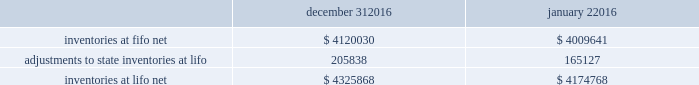Advance auto parts , inc .
And subsidiaries notes to the consolidated financial statements december 31 , 2016 , january 2 , 2016 and january 3 , 2015 ( in thousands , except per share data ) 2 .
Inventories , net : merchandise inventory the company used the lifo method of accounting for approximately 89% ( 89 % ) of inventories at both december 31 , 2016 and january 2 , 2016 .
Under lifo , the company 2019s cost of sales reflects the costs of the most recently purchased inventories , while the inventory carrying balance represents the costs for inventories purchased in 2016 and prior years .
As a result of utilizing lifo , the company recorded a reduction to cost of sales of $ 40711 and $ 42295 in 2016 and 2015 , respectively , and an increase to cost of sales of $ 8930 in 2014 .
Historically , the company 2019s overall costs to acquire inventory for the same or similar products have generally decreased as the company has been able to leverage its continued growth and execution of merchandise strategies .
The increase in cost of sales for 2014 was the result of an increase in supply chain costs .
Product cores the remaining inventories are comprised of product cores , the non-consumable portion of certain parts and batteries and the inventory of certain subsidiaries , which are valued under the first-in , first-out ( 201cfifo 201d ) method .
Product cores are included as part of the company 2019s merchandise costs and are either passed on to the customer or returned to the vendor .
Because product cores are not subject to frequent cost changes like the company 2019s other merchandise inventory , there is no material difference when applying either the lifo or fifo valuation method .
Inventory overhead costs purchasing and warehousing costs included in inventory as of december 31 , 2016 and january 2 , 2016 , were $ 395240 and $ 359829 , respectively .
Inventory balance and inventory reserves inventory balances at the end of 2016 and 2015 were as follows : december 31 , january 2 .
Inventory quantities are tracked through a perpetual inventory system .
The company completes physical inventories and other targeted inventory counts in its store locations to ensure the accuracy of the perpetual inventory quantities of merchandise and core inventory .
In its distribution centers and branches , the company uses a cycle counting program to ensure the accuracy of the perpetual inventory quantities of merchandise and product core inventory .
Reserves for estimated shrink are established based on the results of physical inventories conducted by the company and other targeted inventory counts in its stores , results from recent cycle counts in its distribution facilities and historical and current loss trends .
The company also establishes reserves for potentially excess and obsolete inventories based on ( i ) current inventory levels , ( ii ) the historical analysis of product sales and ( iii ) current market conditions .
The company has return rights with many of its vendors and the majority of excess inventory is returned to its vendors for full credit .
In certain situations , the company establishes reserves when less than full credit is expected from a vendor or when liquidating product will result in retail prices below recorded costs. .
How the cash flow from operations affected by the increase in inventories at lifo net in 2016? 
Computations: (4174768 - 4325868)
Answer: -151100.0. Advance auto parts , inc .
And subsidiaries notes to the consolidated financial statements december 31 , 2016 , january 2 , 2016 and january 3 , 2015 ( in thousands , except per share data ) 2 .
Inventories , net : merchandise inventory the company used the lifo method of accounting for approximately 89% ( 89 % ) of inventories at both december 31 , 2016 and january 2 , 2016 .
Under lifo , the company 2019s cost of sales reflects the costs of the most recently purchased inventories , while the inventory carrying balance represents the costs for inventories purchased in 2016 and prior years .
As a result of utilizing lifo , the company recorded a reduction to cost of sales of $ 40711 and $ 42295 in 2016 and 2015 , respectively , and an increase to cost of sales of $ 8930 in 2014 .
Historically , the company 2019s overall costs to acquire inventory for the same or similar products have generally decreased as the company has been able to leverage its continued growth and execution of merchandise strategies .
The increase in cost of sales for 2014 was the result of an increase in supply chain costs .
Product cores the remaining inventories are comprised of product cores , the non-consumable portion of certain parts and batteries and the inventory of certain subsidiaries , which are valued under the first-in , first-out ( 201cfifo 201d ) method .
Product cores are included as part of the company 2019s merchandise costs and are either passed on to the customer or returned to the vendor .
Because product cores are not subject to frequent cost changes like the company 2019s other merchandise inventory , there is no material difference when applying either the lifo or fifo valuation method .
Inventory overhead costs purchasing and warehousing costs included in inventory as of december 31 , 2016 and january 2 , 2016 , were $ 395240 and $ 359829 , respectively .
Inventory balance and inventory reserves inventory balances at the end of 2016 and 2015 were as follows : december 31 , january 2 .
Inventory quantities are tracked through a perpetual inventory system .
The company completes physical inventories and other targeted inventory counts in its store locations to ensure the accuracy of the perpetual inventory quantities of merchandise and core inventory .
In its distribution centers and branches , the company uses a cycle counting program to ensure the accuracy of the perpetual inventory quantities of merchandise and product core inventory .
Reserves for estimated shrink are established based on the results of physical inventories conducted by the company and other targeted inventory counts in its stores , results from recent cycle counts in its distribution facilities and historical and current loss trends .
The company also establishes reserves for potentially excess and obsolete inventories based on ( i ) current inventory levels , ( ii ) the historical analysis of product sales and ( iii ) current market conditions .
The company has return rights with many of its vendors and the majority of excess inventory is returned to its vendors for full credit .
In certain situations , the company establishes reserves when less than full credit is expected from a vendor or when liquidating product will result in retail prices below recorded costs. .
How the cash flow from operations affected by the increase in inventories at fifo net in 2016? 
Computations: (4009641 - 4120030)
Answer: -110389.0. Advance auto parts , inc .
And subsidiaries notes to the consolidated financial statements december 31 , 2016 , january 2 , 2016 and january 3 , 2015 ( in thousands , except per share data ) 2 .
Inventories , net : merchandise inventory the company used the lifo method of accounting for approximately 89% ( 89 % ) of inventories at both december 31 , 2016 and january 2 , 2016 .
Under lifo , the company 2019s cost of sales reflects the costs of the most recently purchased inventories , while the inventory carrying balance represents the costs for inventories purchased in 2016 and prior years .
As a result of utilizing lifo , the company recorded a reduction to cost of sales of $ 40711 and $ 42295 in 2016 and 2015 , respectively , and an increase to cost of sales of $ 8930 in 2014 .
Historically , the company 2019s overall costs to acquire inventory for the same or similar products have generally decreased as the company has been able to leverage its continued growth and execution of merchandise strategies .
The increase in cost of sales for 2014 was the result of an increase in supply chain costs .
Product cores the remaining inventories are comprised of product cores , the non-consumable portion of certain parts and batteries and the inventory of certain subsidiaries , which are valued under the first-in , first-out ( 201cfifo 201d ) method .
Product cores are included as part of the company 2019s merchandise costs and are either passed on to the customer or returned to the vendor .
Because product cores are not subject to frequent cost changes like the company 2019s other merchandise inventory , there is no material difference when applying either the lifo or fifo valuation method .
Inventory overhead costs purchasing and warehousing costs included in inventory as of december 31 , 2016 and january 2 , 2016 , were $ 395240 and $ 359829 , respectively .
Inventory balance and inventory reserves inventory balances at the end of 2016 and 2015 were as follows : december 31 , january 2 .
Inventory quantities are tracked through a perpetual inventory system .
The company completes physical inventories and other targeted inventory counts in its store locations to ensure the accuracy of the perpetual inventory quantities of merchandise and core inventory .
In its distribution centers and branches , the company uses a cycle counting program to ensure the accuracy of the perpetual inventory quantities of merchandise and product core inventory .
Reserves for estimated shrink are established based on the results of physical inventories conducted by the company and other targeted inventory counts in its stores , results from recent cycle counts in its distribution facilities and historical and current loss trends .
The company also establishes reserves for potentially excess and obsolete inventories based on ( i ) current inventory levels , ( ii ) the historical analysis of product sales and ( iii ) current market conditions .
The company has return rights with many of its vendors and the majority of excess inventory is returned to its vendors for full credit .
In certain situations , the company establishes reserves when less than full credit is expected from a vendor or when liquidating product will result in retail prices below recorded costs. .
How much did the inventory overhead costs purchasing and warehousing costs increase in the year of 2016? 
Rationale: to find how much the company increased its inventory overhead costs and warehousing costs one must subtract the costs at the start of the year by the amount at the end of the year .
Computations: ((395240 - 359829) / 359829)
Answer: 0.09841. 